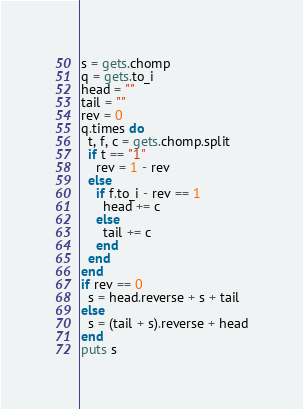Convert code to text. <code><loc_0><loc_0><loc_500><loc_500><_Ruby_>s = gets.chomp
q = gets.to_i
head = ""
tail = ""
rev = 0
q.times do
  t, f, c = gets.chomp.split
  if t == "1"
    rev = 1 - rev
  else
    if f.to_i - rev == 1
      head += c
    else
      tail += c
    end
  end
end
if rev == 0
  s = head.reverse + s + tail
else
  s = (tail + s).reverse + head
end
puts s
</code> 